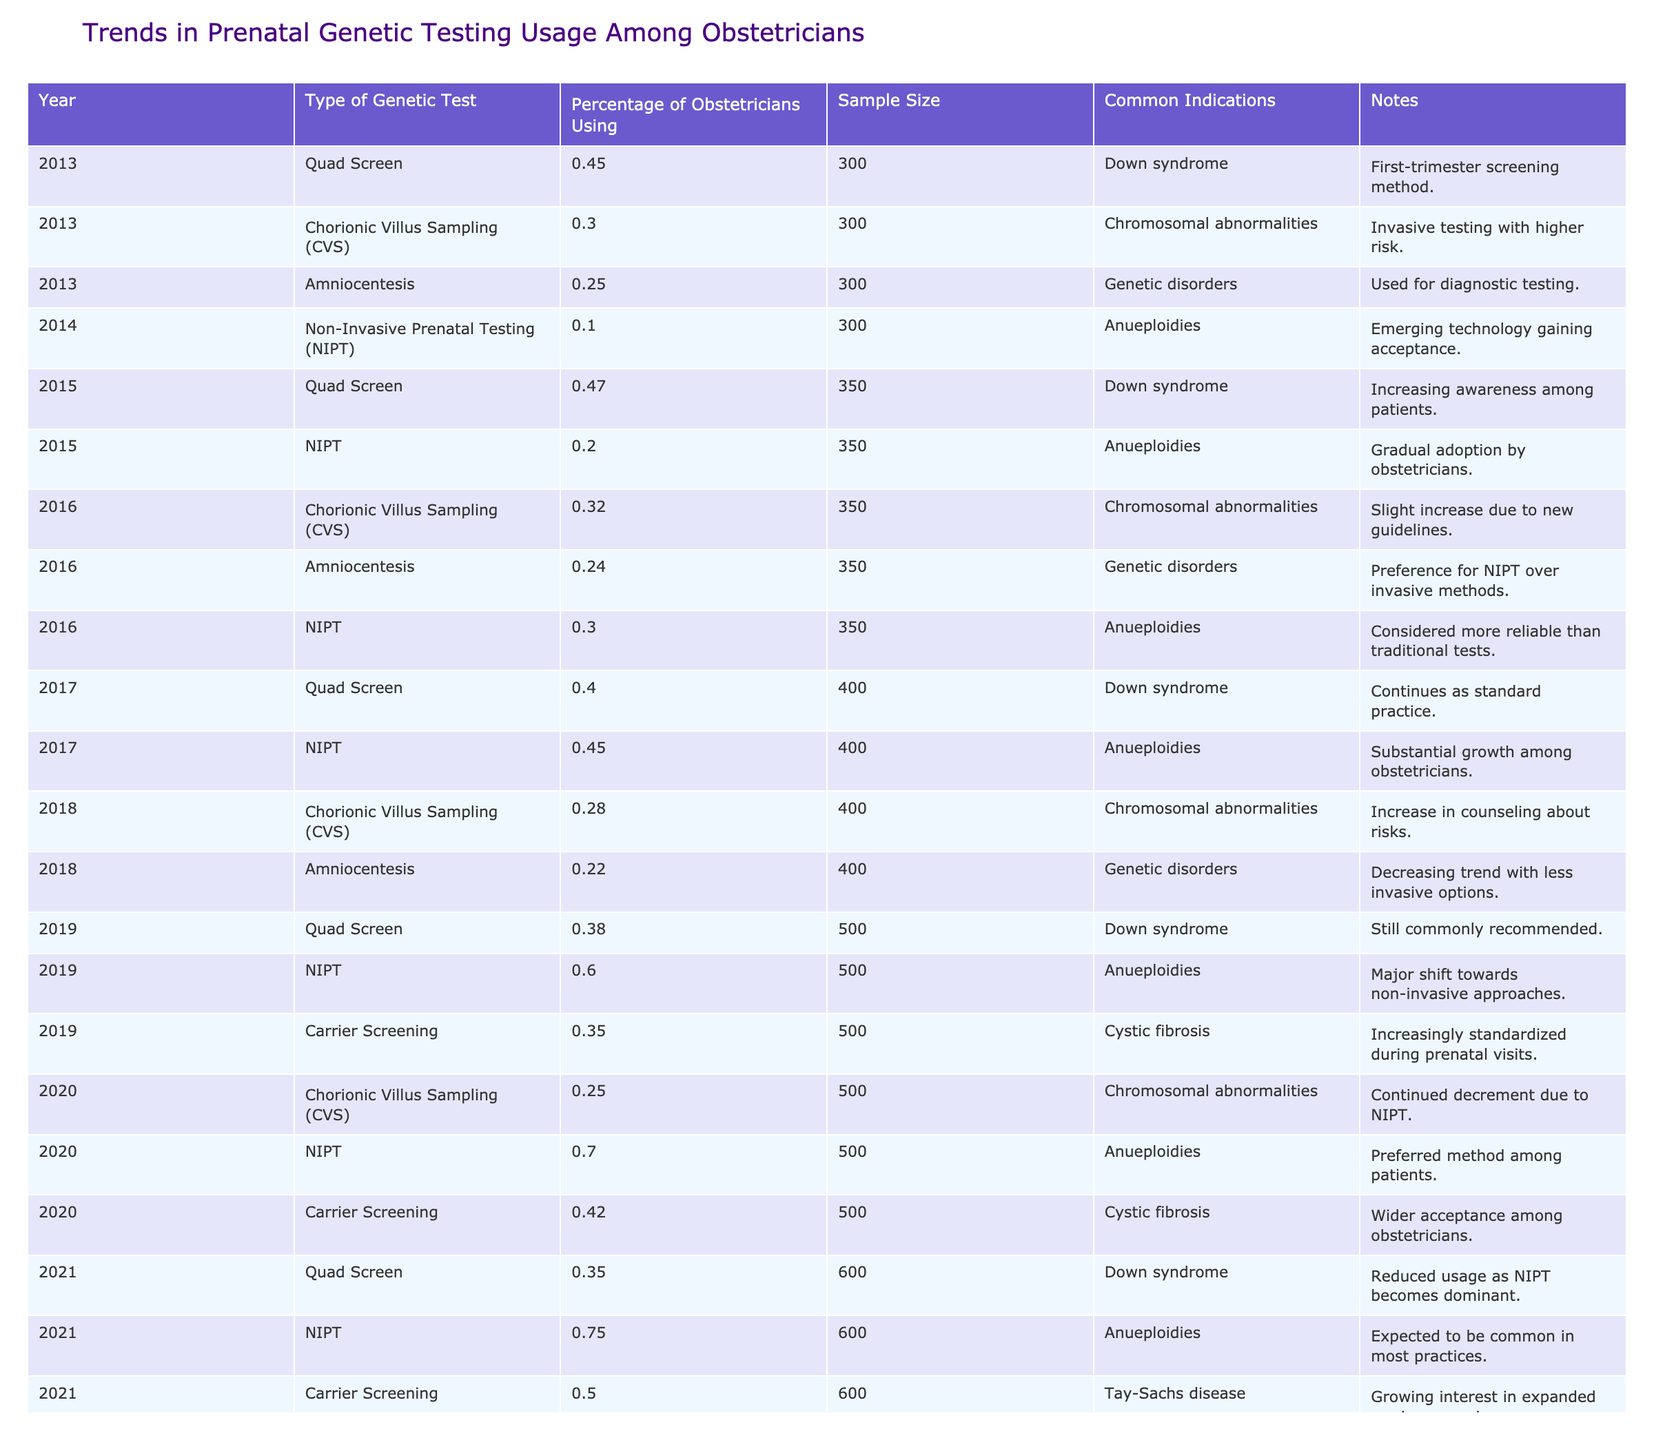What percentage of obstetricians used Non-Invasive Prenatal Testing (NIPT) in 2023? In 2023, the table shows that 85% of obstetricians used NIPT.
Answer: 85% What was the trend in the usage of Amniocentesis from 2013 to 2023? The percentage of obstetricians using Amniocentesis decreased from 25% in 2013 to 22% in 2018 and remained low at 22% in 2023, indicating a declining trend.
Answer: Declining trend In 2021, what was the percentage usage of Carrier Screening among obstetricians? The table indicates that in 2021, 50% of obstetricians were using Carrier Screening.
Answer: 50% What is the difference in percentage of obstetricians using Quad Screen between 2019 and 2021? In 2019, 38% were using Quad Screen, while in 2021, it was 35%. Therefore, the difference is 38% - 35% = 3%.
Answer: 3% What type of genetic test saw the most significant increase in usage from 2019 to 2023? From 2019 when NIPT usage was 60% to 2023 when it reached 85%, NIPT saw an increase of 25%. Comparing other tests, no other test had such a substantial increase during that period.
Answer: NIPT In 2022, what percentage of obstetricians used Carrier Screening? According to the table, 55% of obstetricians used Carrier Screening in 2022.
Answer: 55% Which genetic test had the highest usage percentage in 2020 among obstetricians? The table shows that in 2020, NIPT had the highest percentage of usage at 70%.
Answer: NIPT Comparing the years that had the highest percentage usage of NIPT, how much did it increase from 2020 to 2023? In 2020, NIPT was used by 70% of obstetricians, and in 2023, it rose to 85%. This represents an increase of 85% - 70% = 15%.
Answer: 15% Was the usage percentage of Chorionic Villus Sampling (CVS) higher in 2013 or 2023? The table indicates that CVS was used by 30% of obstetricians in 2013, while in 2023, it dropped to 20%. Thus, it was higher in 2013.
Answer: 2013 What was the most common indication for non-invasive prenatal testing as per the table? The table states that the common indication for non-invasive prenatal testing (NIPT) is aneuploidies.
Answer: Aneuploidies What percentage of obstetricians used Amniocentesis in 2019, and how does this compare to its usage in 2016? In 2019, 22% of obstetricians used Amniocentesis, while in 2016, it was 24%. This indicates a decrease of 2%.
Answer: 22%, decreased by 2% 